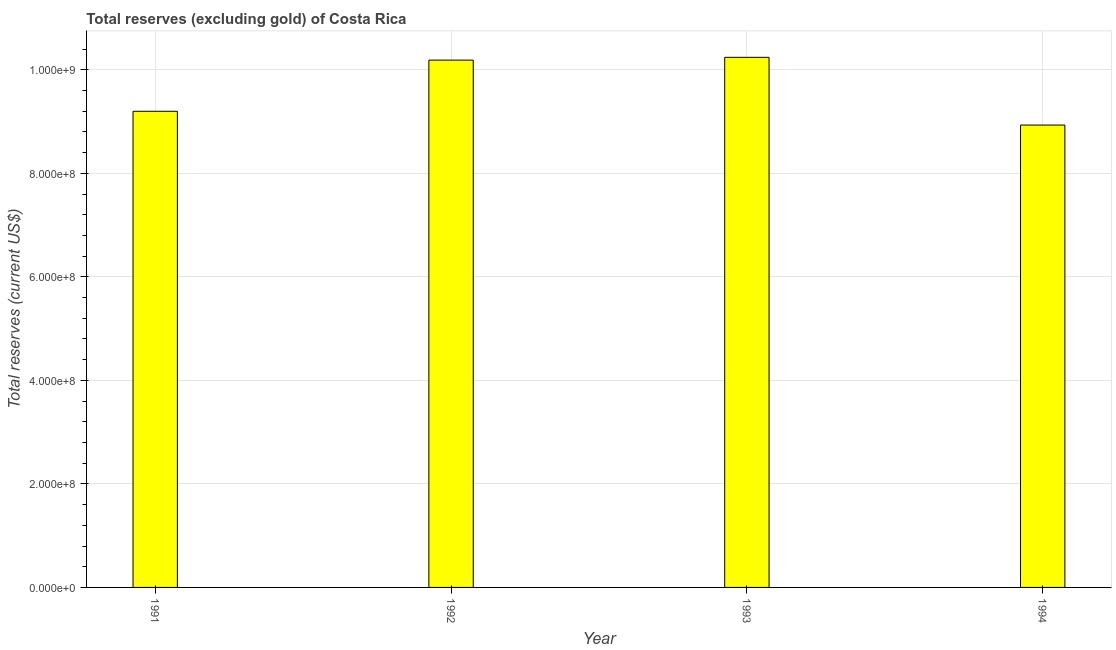Does the graph contain grids?
Your response must be concise. Yes. What is the title of the graph?
Make the answer very short. Total reserves (excluding gold) of Costa Rica. What is the label or title of the X-axis?
Provide a short and direct response. Year. What is the label or title of the Y-axis?
Your answer should be compact. Total reserves (current US$). What is the total reserves (excluding gold) in 1991?
Make the answer very short. 9.20e+08. Across all years, what is the maximum total reserves (excluding gold)?
Offer a terse response. 1.02e+09. Across all years, what is the minimum total reserves (excluding gold)?
Offer a terse response. 8.93e+08. In which year was the total reserves (excluding gold) maximum?
Ensure brevity in your answer.  1993. In which year was the total reserves (excluding gold) minimum?
Your response must be concise. 1994. What is the sum of the total reserves (excluding gold)?
Keep it short and to the point. 3.86e+09. What is the difference between the total reserves (excluding gold) in 1992 and 1993?
Your answer should be compact. -5.38e+06. What is the average total reserves (excluding gold) per year?
Provide a short and direct response. 9.64e+08. What is the median total reserves (excluding gold)?
Give a very brief answer. 9.69e+08. In how many years, is the total reserves (excluding gold) greater than 880000000 US$?
Offer a very short reply. 4. Do a majority of the years between 1993 and 1992 (inclusive) have total reserves (excluding gold) greater than 440000000 US$?
Ensure brevity in your answer.  No. What is the ratio of the total reserves (excluding gold) in 1991 to that in 1993?
Your response must be concise. 0.9. Is the difference between the total reserves (excluding gold) in 1992 and 1993 greater than the difference between any two years?
Give a very brief answer. No. What is the difference between the highest and the second highest total reserves (excluding gold)?
Provide a succinct answer. 5.38e+06. Is the sum of the total reserves (excluding gold) in 1991 and 1992 greater than the maximum total reserves (excluding gold) across all years?
Offer a very short reply. Yes. What is the difference between the highest and the lowest total reserves (excluding gold)?
Your response must be concise. 1.31e+08. In how many years, is the total reserves (excluding gold) greater than the average total reserves (excluding gold) taken over all years?
Ensure brevity in your answer.  2. How many bars are there?
Ensure brevity in your answer.  4. Are all the bars in the graph horizontal?
Give a very brief answer. No. How many years are there in the graph?
Offer a very short reply. 4. Are the values on the major ticks of Y-axis written in scientific E-notation?
Provide a short and direct response. Yes. What is the Total reserves (current US$) in 1991?
Provide a succinct answer. 9.20e+08. What is the Total reserves (current US$) of 1992?
Your answer should be compact. 1.02e+09. What is the Total reserves (current US$) of 1993?
Provide a succinct answer. 1.02e+09. What is the Total reserves (current US$) of 1994?
Your answer should be very brief. 8.93e+08. What is the difference between the Total reserves (current US$) in 1991 and 1992?
Your answer should be compact. -9.88e+07. What is the difference between the Total reserves (current US$) in 1991 and 1993?
Your response must be concise. -1.04e+08. What is the difference between the Total reserves (current US$) in 1991 and 1994?
Provide a succinct answer. 2.66e+07. What is the difference between the Total reserves (current US$) in 1992 and 1993?
Offer a terse response. -5.38e+06. What is the difference between the Total reserves (current US$) in 1992 and 1994?
Offer a terse response. 1.25e+08. What is the difference between the Total reserves (current US$) in 1993 and 1994?
Offer a terse response. 1.31e+08. What is the ratio of the Total reserves (current US$) in 1991 to that in 1992?
Provide a short and direct response. 0.9. What is the ratio of the Total reserves (current US$) in 1991 to that in 1993?
Give a very brief answer. 0.9. What is the ratio of the Total reserves (current US$) in 1992 to that in 1994?
Keep it short and to the point. 1.14. What is the ratio of the Total reserves (current US$) in 1993 to that in 1994?
Your answer should be compact. 1.15. 